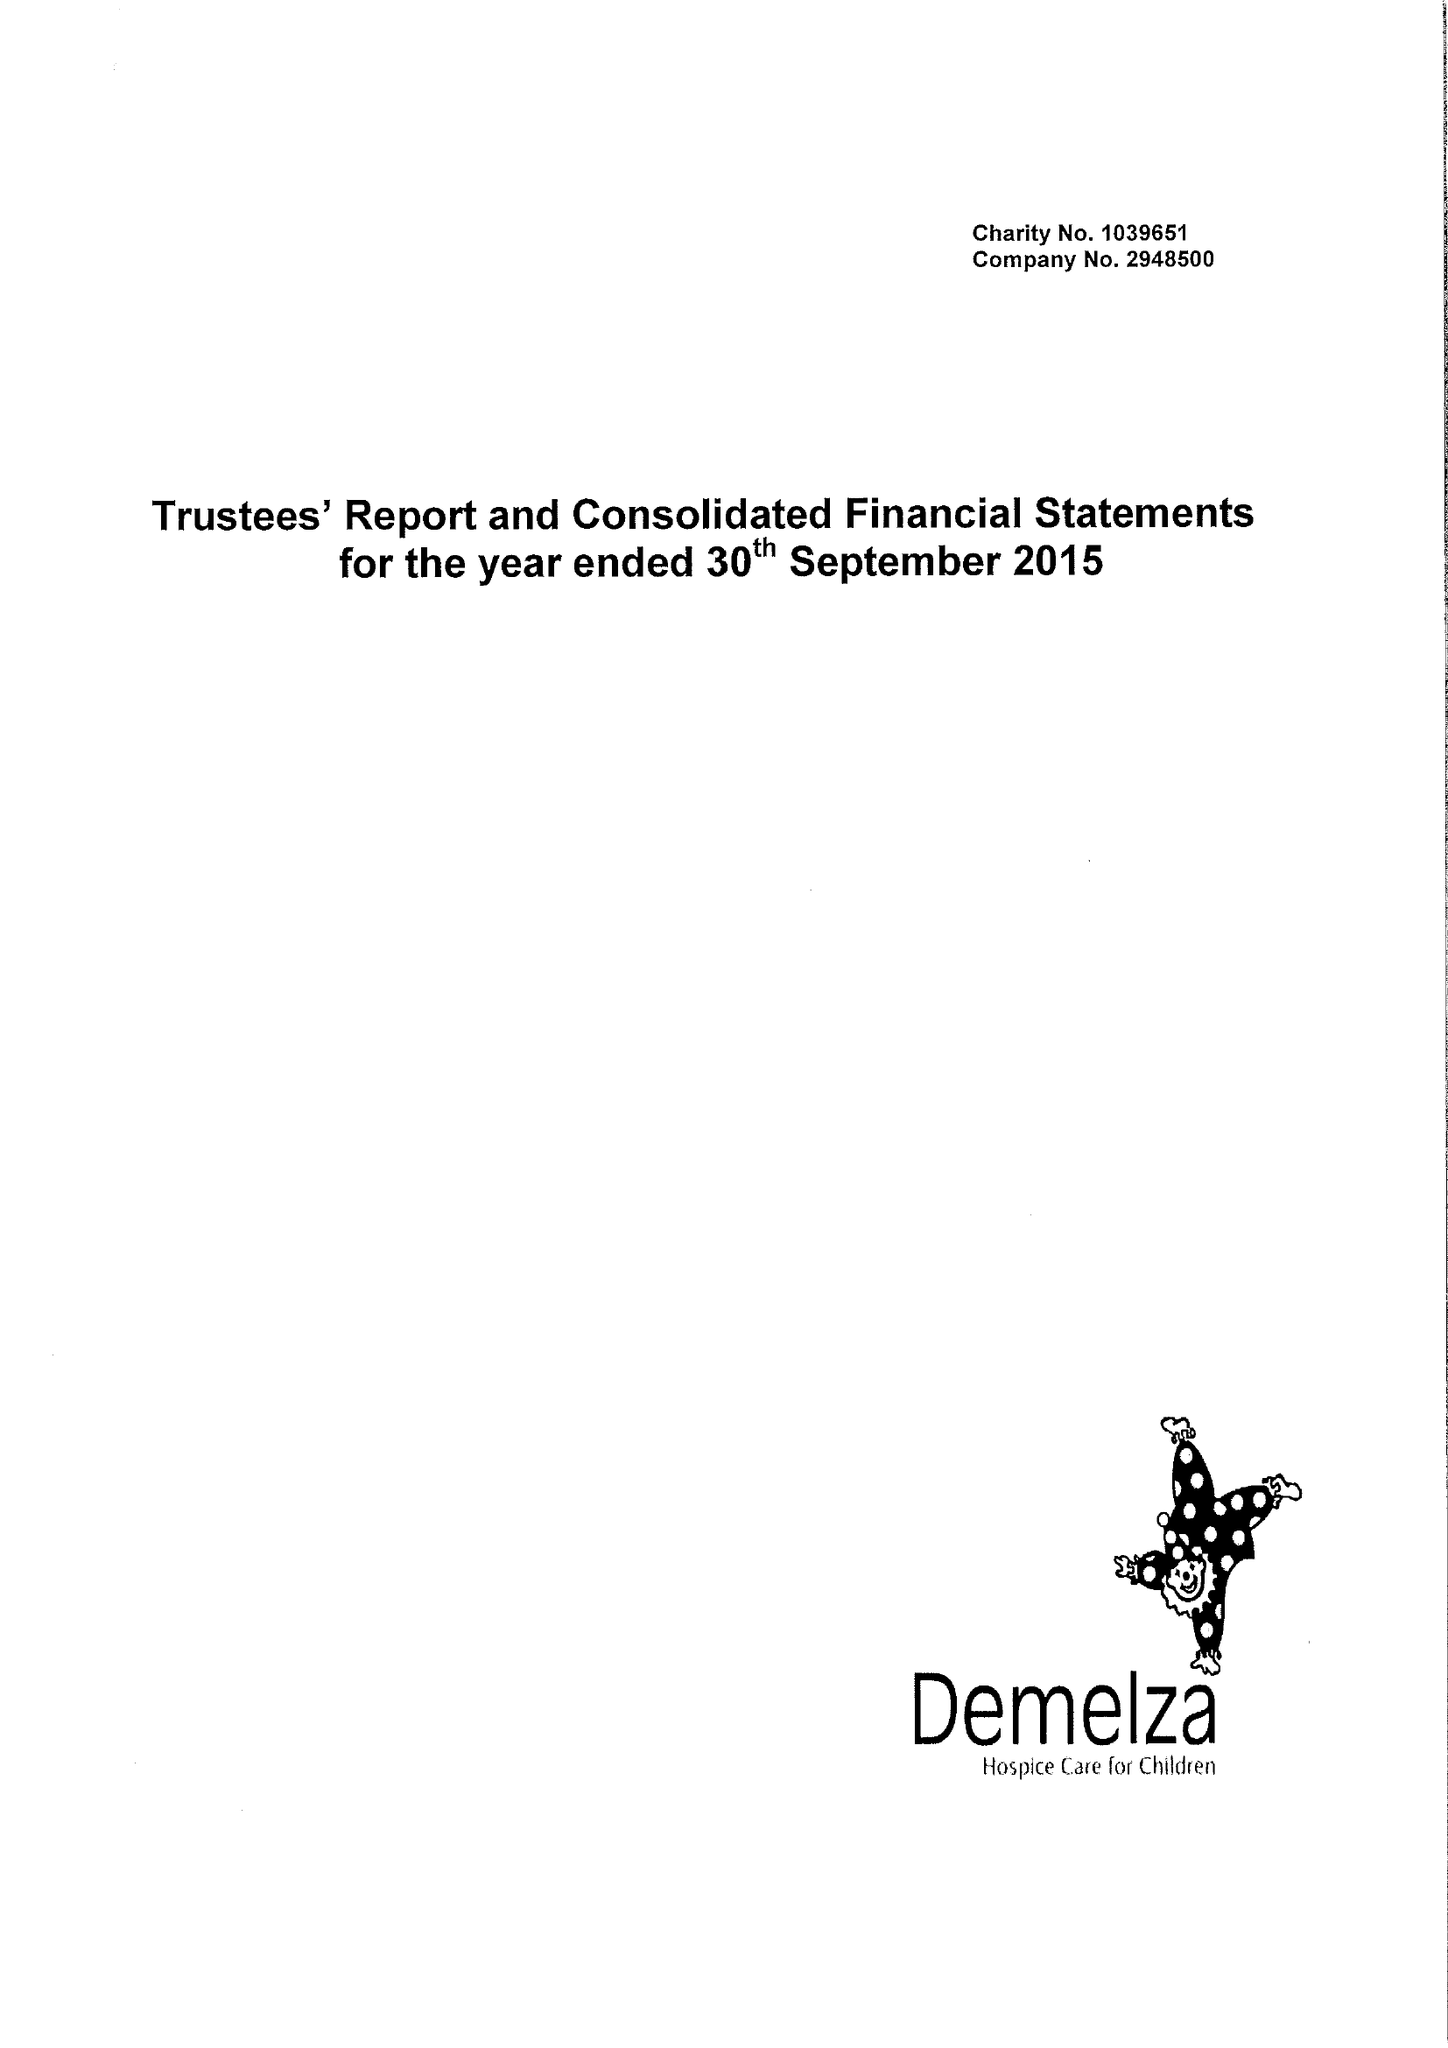What is the value for the address__postcode?
Answer the question using a single word or phrase. ME9 8DZ 